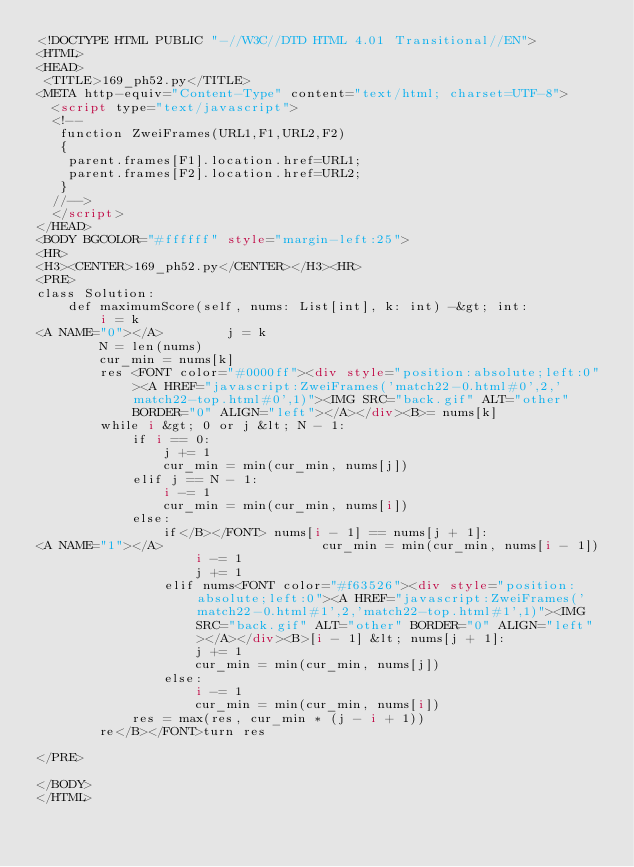<code> <loc_0><loc_0><loc_500><loc_500><_HTML_><!DOCTYPE HTML PUBLIC "-//W3C//DTD HTML 4.01 Transitional//EN">
<HTML>
<HEAD>
 <TITLE>169_ph52.py</TITLE>
<META http-equiv="Content-Type" content="text/html; charset=UTF-8">
  <script type="text/javascript">
  <!--
   function ZweiFrames(URL1,F1,URL2,F2)
   {
    parent.frames[F1].location.href=URL1;
    parent.frames[F2].location.href=URL2;
   }
  //-->
  </script>
</HEAD>
<BODY BGCOLOR="#ffffff" style="margin-left:25">
<HR>
<H3><CENTER>169_ph52.py</CENTER></H3><HR>
<PRE>
class Solution:
    def maximumScore(self, nums: List[int], k: int) -&gt; int:
        i = k
<A NAME="0"></A>        j = k
        N = len(nums)
        cur_min = nums[k]
        res <FONT color="#0000ff"><div style="position:absolute;left:0"><A HREF="javascript:ZweiFrames('match22-0.html#0',2,'match22-top.html#0',1)"><IMG SRC="back.gif" ALT="other" BORDER="0" ALIGN="left"></A></div><B>= nums[k]
        while i &gt; 0 or j &lt; N - 1:
            if i == 0:
                j += 1
                cur_min = min(cur_min, nums[j])
            elif j == N - 1:
                i -= 1
                cur_min = min(cur_min, nums[i])
            else:
                if</B></FONT> nums[i - 1] == nums[j + 1]:
<A NAME="1"></A>                    cur_min = min(cur_min, nums[i - 1])
                    i -= 1
                    j += 1
                elif nums<FONT color="#f63526"><div style="position:absolute;left:0"><A HREF="javascript:ZweiFrames('match22-0.html#1',2,'match22-top.html#1',1)"><IMG SRC="back.gif" ALT="other" BORDER="0" ALIGN="left"></A></div><B>[i - 1] &lt; nums[j + 1]:
                    j += 1
                    cur_min = min(cur_min, nums[j])
                else:
                    i -= 1
                    cur_min = min(cur_min, nums[i])
            res = max(res, cur_min * (j - i + 1))
        re</B></FONT>turn res
    
</PRE>

</BODY>
</HTML>
</code> 